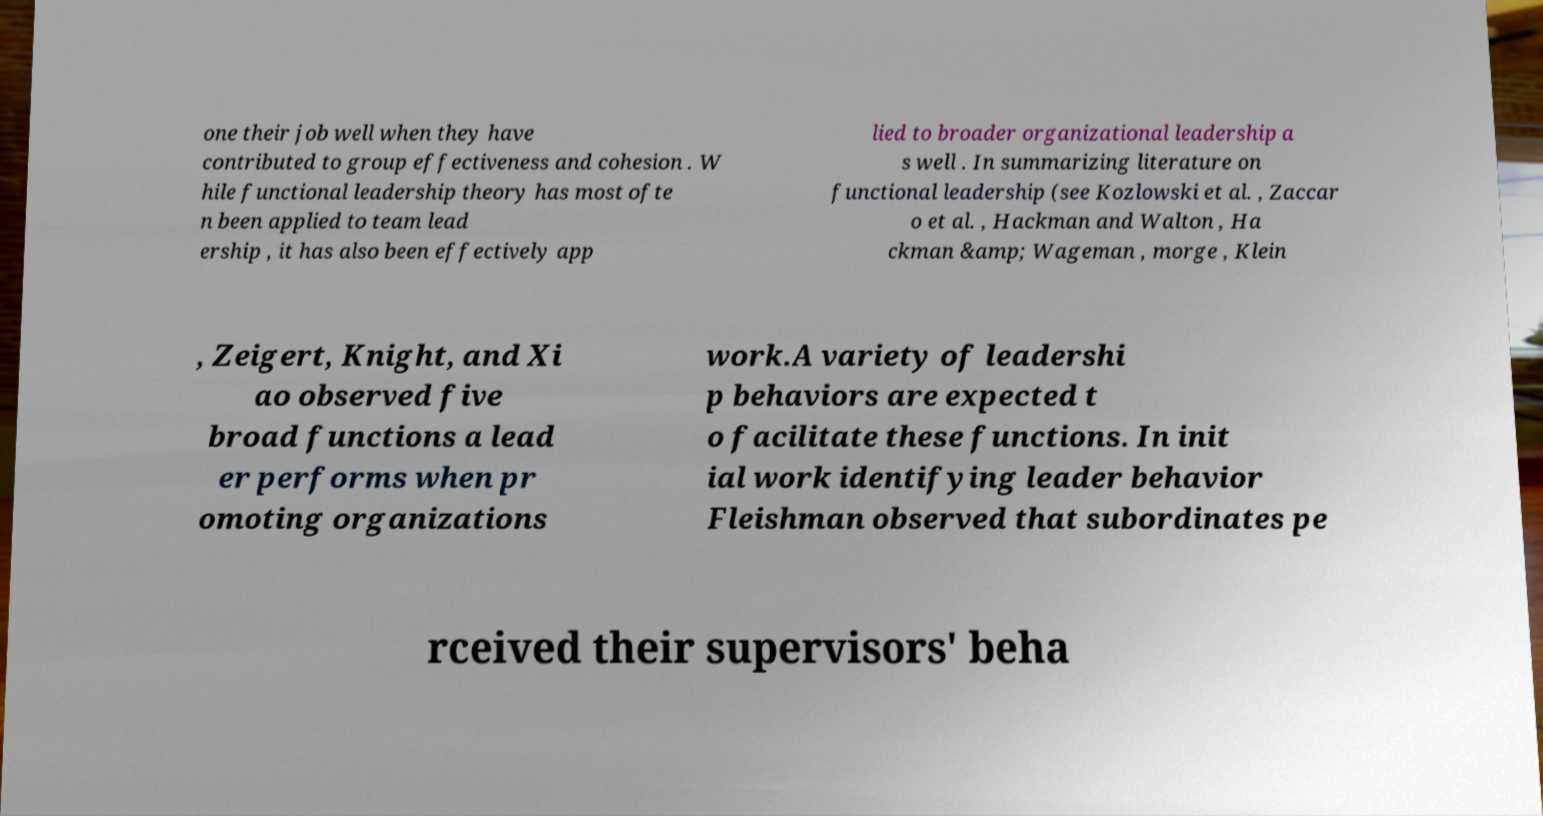Can you read and provide the text displayed in the image?This photo seems to have some interesting text. Can you extract and type it out for me? one their job well when they have contributed to group effectiveness and cohesion . W hile functional leadership theory has most ofte n been applied to team lead ership , it has also been effectively app lied to broader organizational leadership a s well . In summarizing literature on functional leadership (see Kozlowski et al. , Zaccar o et al. , Hackman and Walton , Ha ckman &amp; Wageman , morge , Klein , Zeigert, Knight, and Xi ao observed five broad functions a lead er performs when pr omoting organizations work.A variety of leadershi p behaviors are expected t o facilitate these functions. In init ial work identifying leader behavior Fleishman observed that subordinates pe rceived their supervisors' beha 